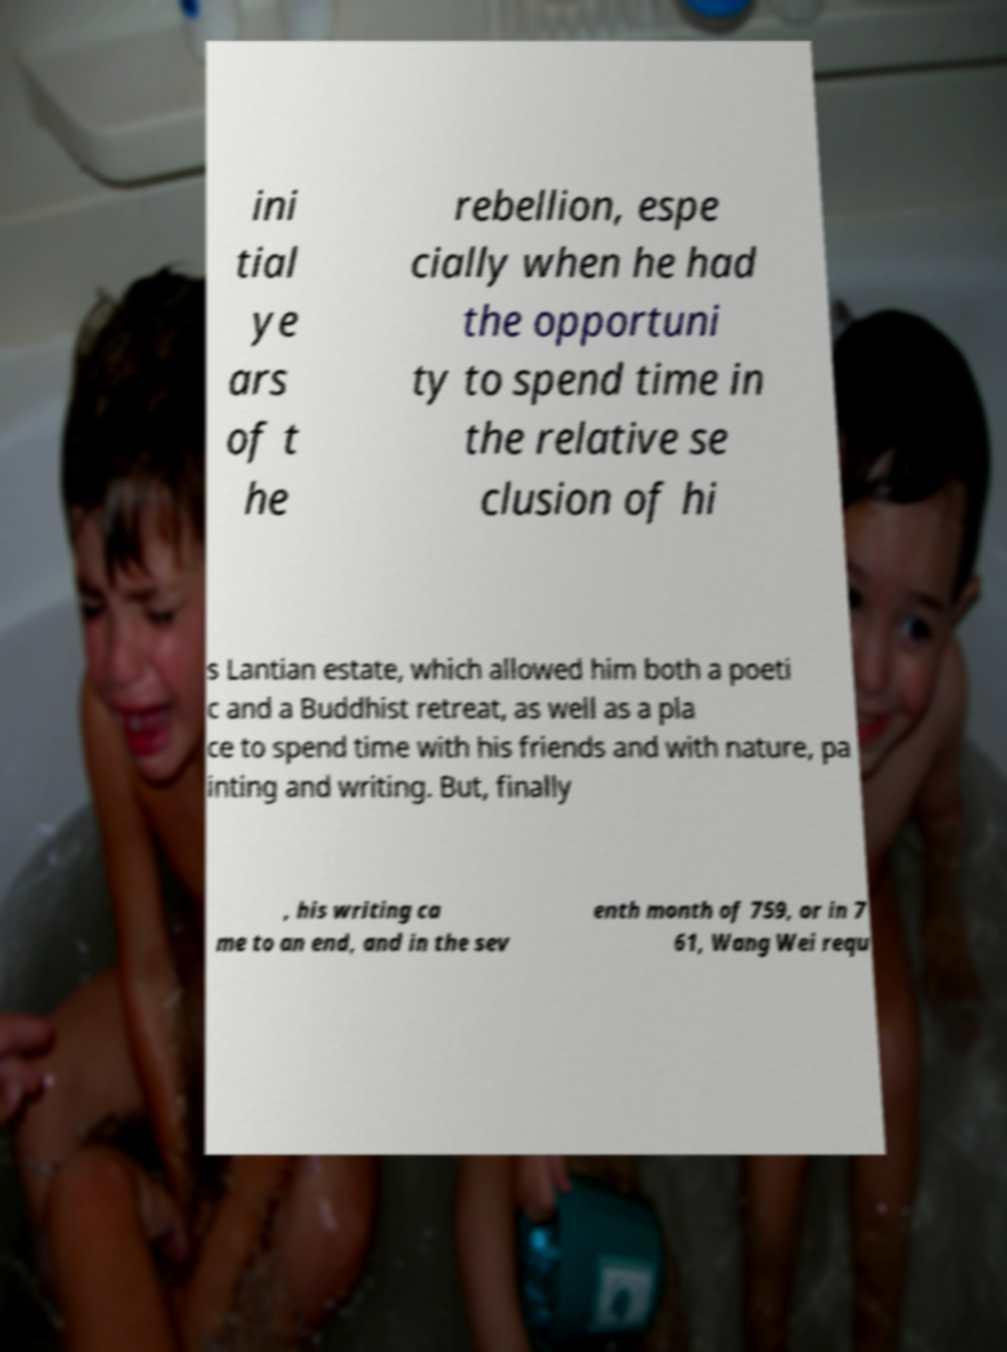I need the written content from this picture converted into text. Can you do that? ini tial ye ars of t he rebellion, espe cially when he had the opportuni ty to spend time in the relative se clusion of hi s Lantian estate, which allowed him both a poeti c and a Buddhist retreat, as well as a pla ce to spend time with his friends and with nature, pa inting and writing. But, finally , his writing ca me to an end, and in the sev enth month of 759, or in 7 61, Wang Wei requ 